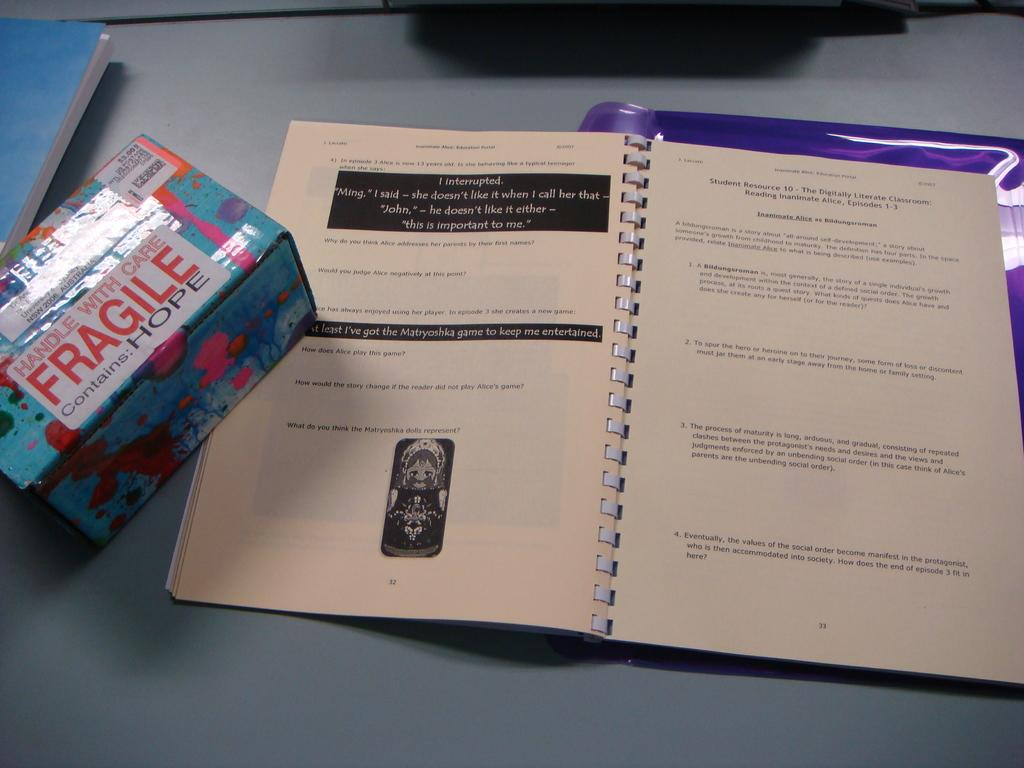<image>
Share a concise interpretation of the image provided. Booklet next to a box that says fragile on the front 